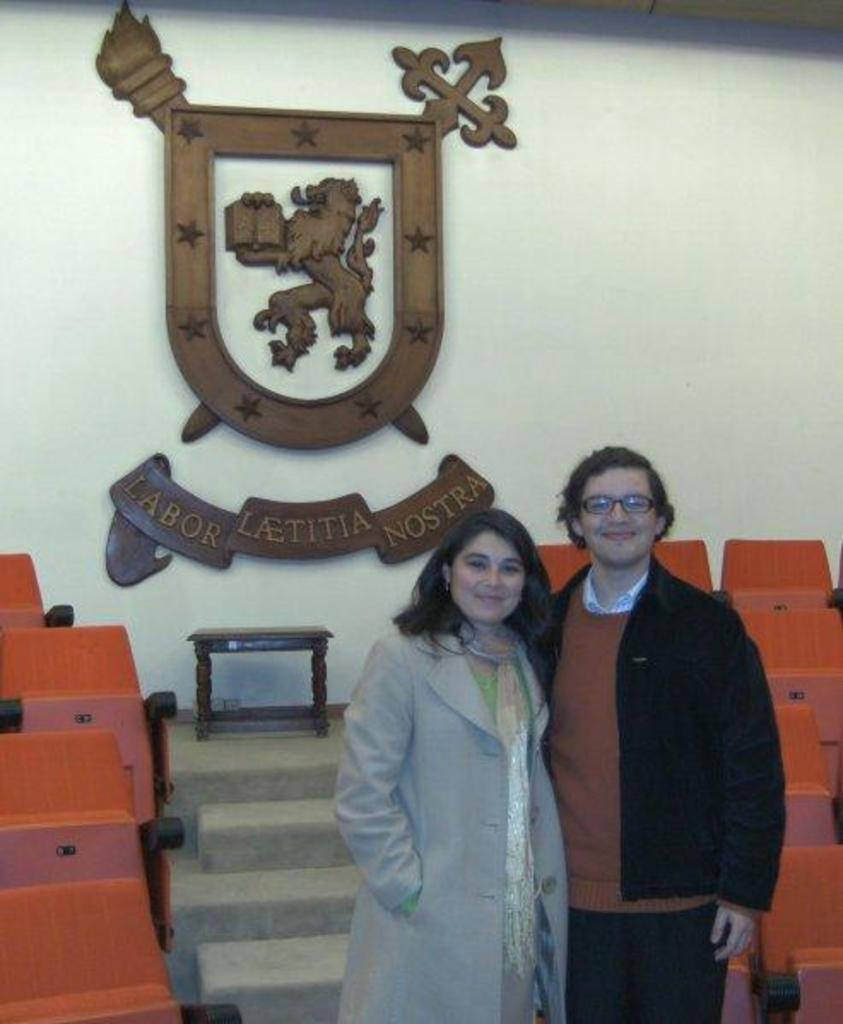How many people are present in the image? There are two people standing in the image. What objects are in the image that people might sit on? There are chairs in the image. What architectural feature is present in the image? There are steps in the image. What can be seen on the wall in the image? There is an emblem on the wall in the image. How many baskets are being used by the people in the image? There are no baskets present in the image. What number is written on the emblem in the image? The emblem in the image does not have a number written on it. 